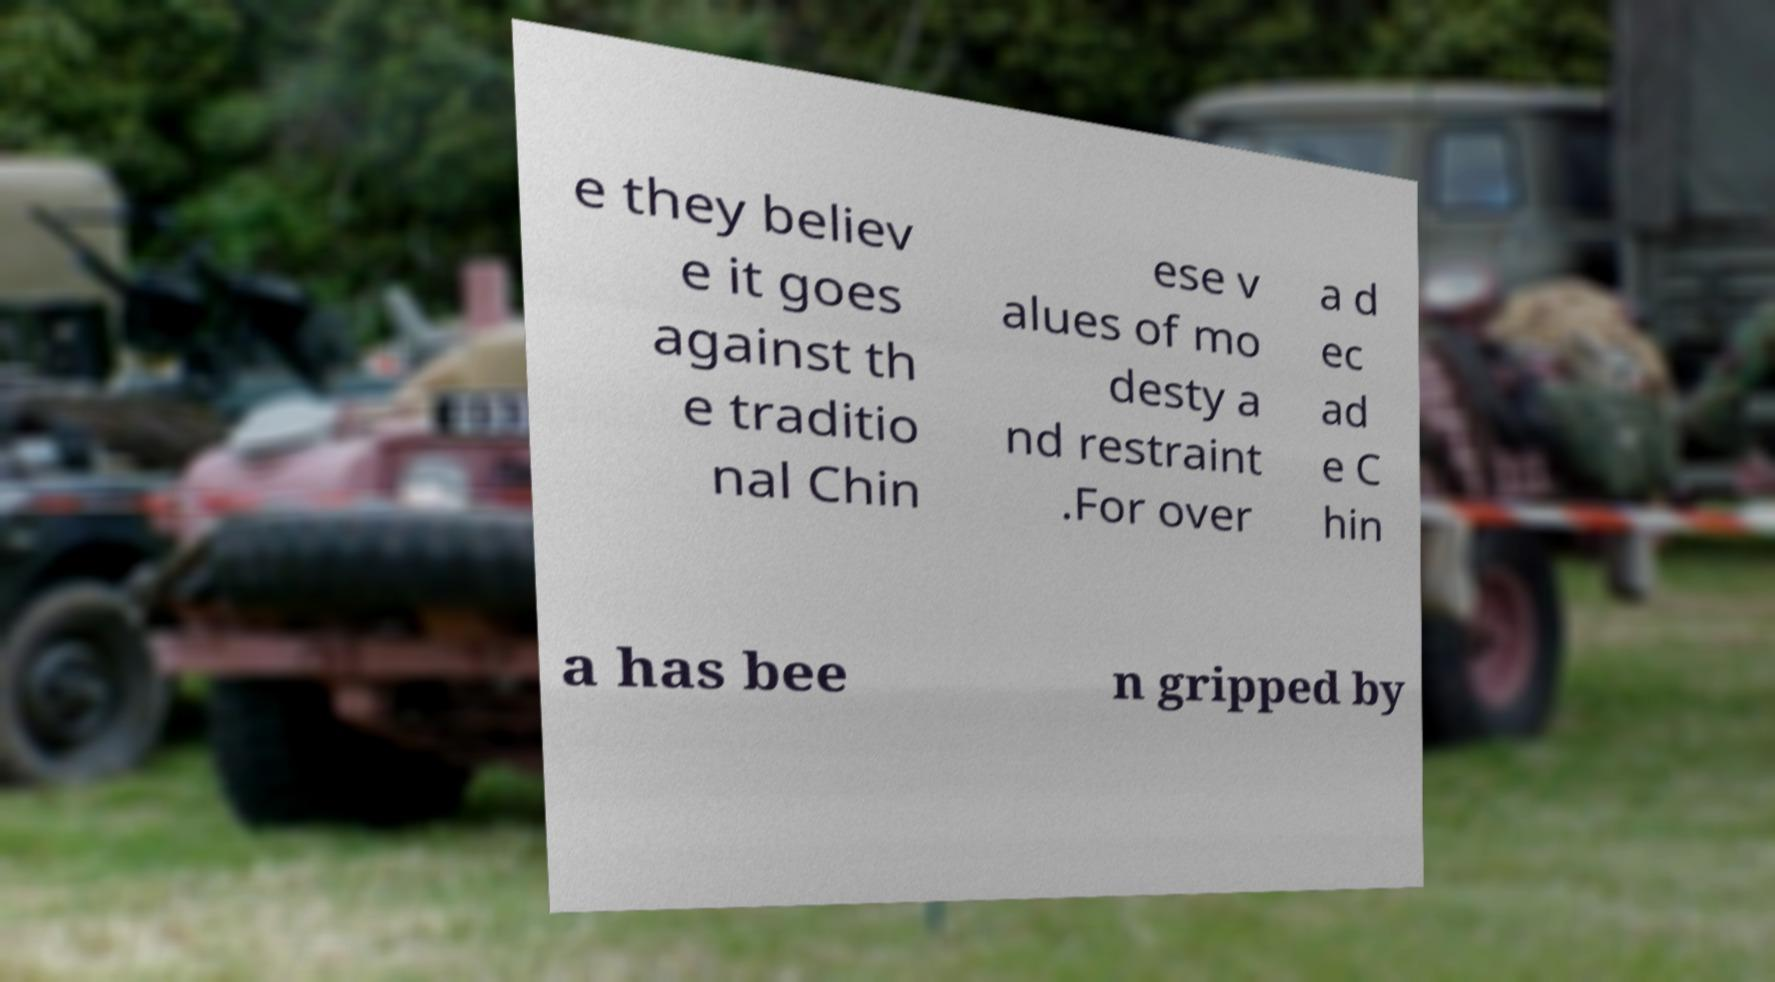Please identify and transcribe the text found in this image. e they believ e it goes against th e traditio nal Chin ese v alues of mo desty a nd restraint .For over a d ec ad e C hin a has bee n gripped by 